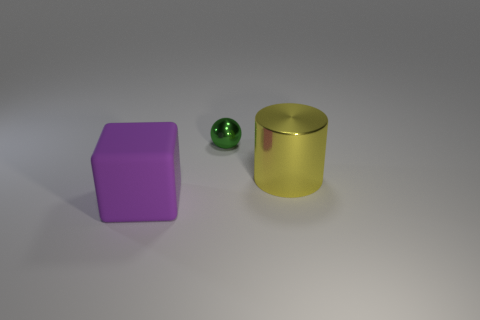There is a thing that is made of the same material as the sphere; what shape is it? cylinder 